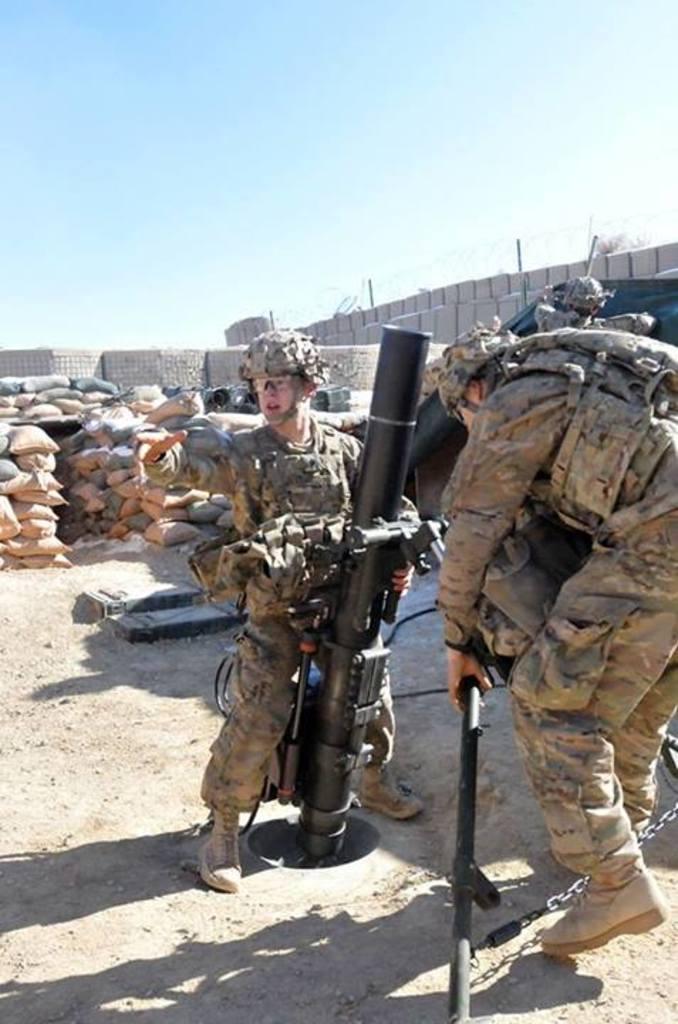Could you give a brief overview of what you see in this image? There is a person in the foreground it seems like holding a missile, there are people on the right side and there are sacks, other objects and sky in the background area. 